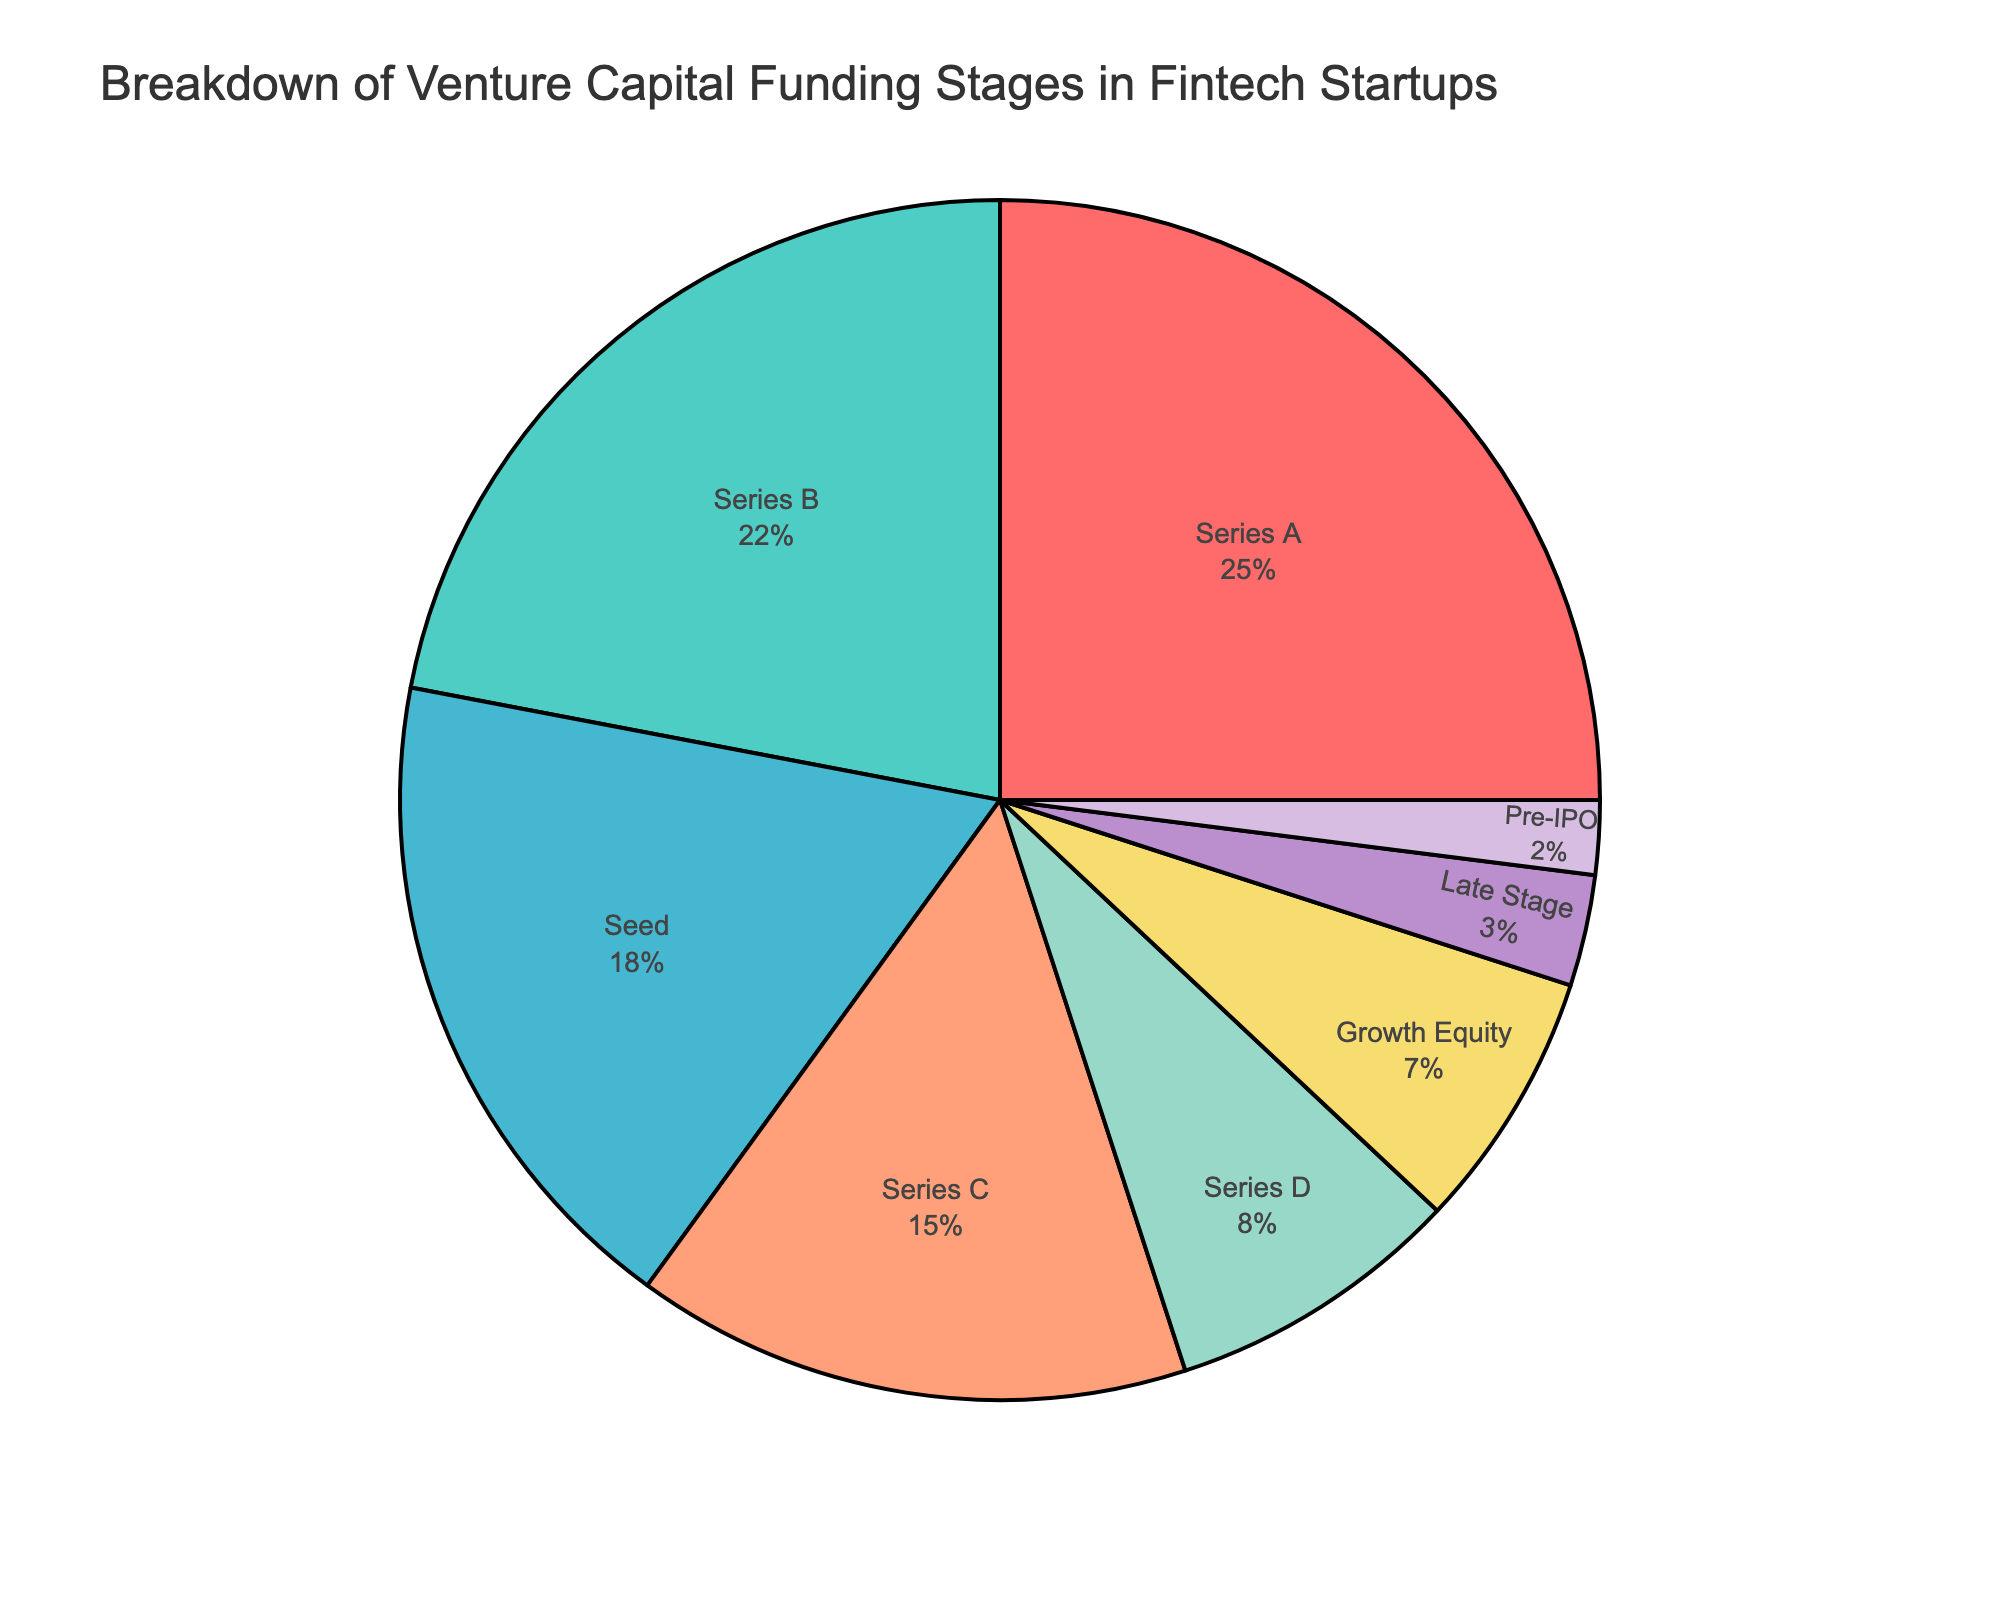What percentage of funding is either in Seed or Series A stages? To find the percentage of funding in both Seed and Series A stages, sum up the percentages of these two stages: Seed (18%) + Series A (25%) = 43%
Answer: 43% Which funding stage receives the least percentage of venture capital? Looking at the pie chart, the smallest slice corresponds to Pre-IPO stage, which is 2%
Answer: Pre-IPO How does the percentage of funding in Series B compare to the percentage in Series D? The percentage of funding in Series B (22%) is compared to Series D (8%). Series B has more funding as 22% > 8%
Answer: Series B Is the percentage of funding for Series A greater than the sum of Late Stage and Pre-IPO funding? The percentage of funding for Series A is 25%. Sum the percentages for Late Stage (3%) and Pre-IPO (2%): 3% + 2% = 5%. Since 25% > 5%, Series A funding is greater
Answer: Yes What is the combined percentage of Growth Equity and Late Stage funding? Sum the percentages for Growth Equity (7%) and Late Stage (3%): 7% + 3% = 10%
Answer: 10% By how much does the percentage of Series C outstrip the percentage of Growth Equity? Series C (15%) is compared to Growth Equity (7%). The difference is 15% - 7% = 8%
Answer: 8% Which stage has a visually distinctive color indicating a higher percentage compared to Pre-IPO? From the visual inspection, the distinct color for Series A (25%) indicative of higher percentage compared to Pre-IPO (2%).
Answer: Series B 